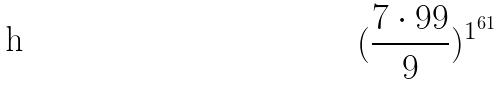<formula> <loc_0><loc_0><loc_500><loc_500>( \frac { 7 \cdot 9 9 } { 9 } ) ^ { 1 ^ { 6 1 } }</formula> 